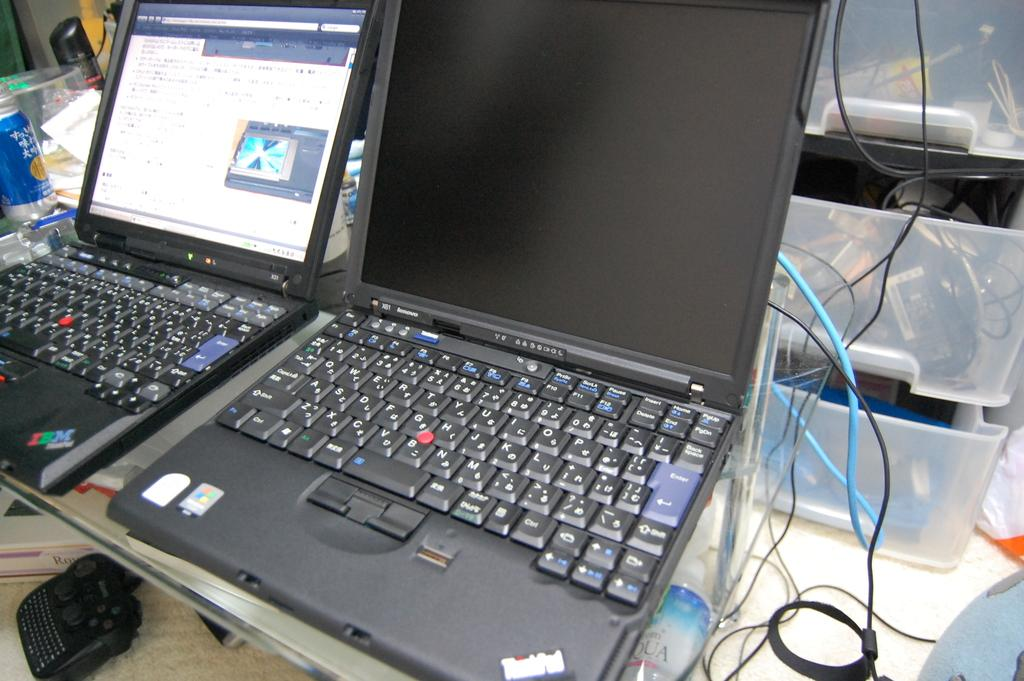Provide a one-sentence caption for the provided image. The laptop on the counter has a IBM sticker on it. 